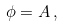<formula> <loc_0><loc_0><loc_500><loc_500>\phi = A \, ,</formula> 